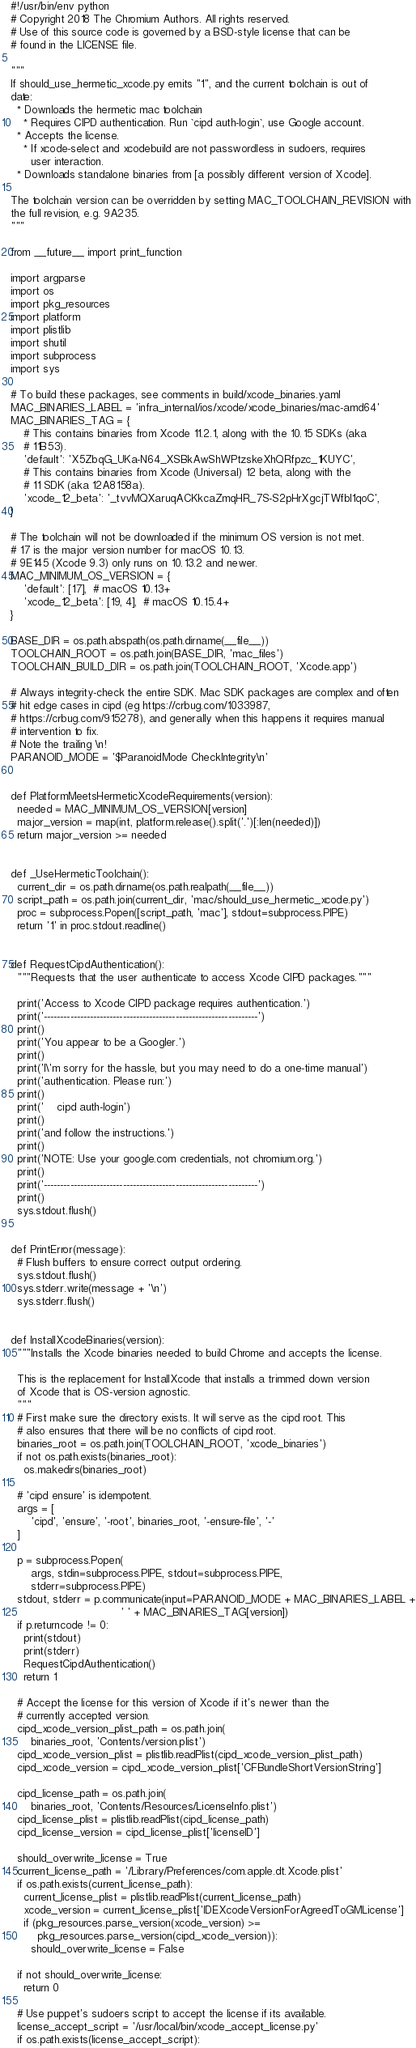<code> <loc_0><loc_0><loc_500><loc_500><_Python_>#!/usr/bin/env python
# Copyright 2018 The Chromium Authors. All rights reserved.
# Use of this source code is governed by a BSD-style license that can be
# found in the LICENSE file.

"""
If should_use_hermetic_xcode.py emits "1", and the current toolchain is out of
date:
  * Downloads the hermetic mac toolchain
    * Requires CIPD authentication. Run `cipd auth-login`, use Google account.
  * Accepts the license.
    * If xcode-select and xcodebuild are not passwordless in sudoers, requires
      user interaction.
  * Downloads standalone binaries from [a possibly different version of Xcode].

The toolchain version can be overridden by setting MAC_TOOLCHAIN_REVISION with
the full revision, e.g. 9A235.
"""

from __future__ import print_function

import argparse
import os
import pkg_resources
import platform
import plistlib
import shutil
import subprocess
import sys

# To build these packages, see comments in build/xcode_binaries.yaml
MAC_BINARIES_LABEL = 'infra_internal/ios/xcode/xcode_binaries/mac-amd64'
MAC_BINARIES_TAG = {
    # This contains binaries from Xcode 11.2.1, along with the 10.15 SDKs (aka
    # 11B53).
    'default': 'X5ZbqG_UKa-N64_XSBkAwShWPtzskeXhQRfpzc_1KUYC',
    # This contains binaries from Xcode (Universal) 12 beta, along with the
    # 11 SDK (aka 12A8158a).
    'xcode_12_beta': '_tvvMQXaruqACKkcaZmqHR_7S-S2pHrXgcjTWfbI1qoC',
}

# The toolchain will not be downloaded if the minimum OS version is not met.
# 17 is the major version number for macOS 10.13.
# 9E145 (Xcode 9.3) only runs on 10.13.2 and newer.
MAC_MINIMUM_OS_VERSION = {
    'default': [17],  # macOS 10.13+
    'xcode_12_beta': [19, 4],  # macOS 10.15.4+
}

BASE_DIR = os.path.abspath(os.path.dirname(__file__))
TOOLCHAIN_ROOT = os.path.join(BASE_DIR, 'mac_files')
TOOLCHAIN_BUILD_DIR = os.path.join(TOOLCHAIN_ROOT, 'Xcode.app')

# Always integrity-check the entire SDK. Mac SDK packages are complex and often
# hit edge cases in cipd (eg https://crbug.com/1033987,
# https://crbug.com/915278), and generally when this happens it requires manual
# intervention to fix.
# Note the trailing \n!
PARANOID_MODE = '$ParanoidMode CheckIntegrity\n'


def PlatformMeetsHermeticXcodeRequirements(version):
  needed = MAC_MINIMUM_OS_VERSION[version]
  major_version = map(int, platform.release().split('.')[:len(needed)])
  return major_version >= needed


def _UseHermeticToolchain():
  current_dir = os.path.dirname(os.path.realpath(__file__))
  script_path = os.path.join(current_dir, 'mac/should_use_hermetic_xcode.py')
  proc = subprocess.Popen([script_path, 'mac'], stdout=subprocess.PIPE)
  return '1' in proc.stdout.readline()


def RequestCipdAuthentication():
  """Requests that the user authenticate to access Xcode CIPD packages."""

  print('Access to Xcode CIPD package requires authentication.')
  print('-----------------------------------------------------------------')
  print()
  print('You appear to be a Googler.')
  print()
  print('I\'m sorry for the hassle, but you may need to do a one-time manual')
  print('authentication. Please run:')
  print()
  print('    cipd auth-login')
  print()
  print('and follow the instructions.')
  print()
  print('NOTE: Use your google.com credentials, not chromium.org.')
  print()
  print('-----------------------------------------------------------------')
  print()
  sys.stdout.flush()


def PrintError(message):
  # Flush buffers to ensure correct output ordering.
  sys.stdout.flush()
  sys.stderr.write(message + '\n')
  sys.stderr.flush()


def InstallXcodeBinaries(version):
  """Installs the Xcode binaries needed to build Chrome and accepts the license.

  This is the replacement for InstallXcode that installs a trimmed down version
  of Xcode that is OS-version agnostic.
  """
  # First make sure the directory exists. It will serve as the cipd root. This
  # also ensures that there will be no conflicts of cipd root.
  binaries_root = os.path.join(TOOLCHAIN_ROOT, 'xcode_binaries')
  if not os.path.exists(binaries_root):
    os.makedirs(binaries_root)

  # 'cipd ensure' is idempotent.
  args = [
      'cipd', 'ensure', '-root', binaries_root, '-ensure-file', '-'
  ]

  p = subprocess.Popen(
      args, stdin=subprocess.PIPE, stdout=subprocess.PIPE,
      stderr=subprocess.PIPE)
  stdout, stderr = p.communicate(input=PARANOID_MODE + MAC_BINARIES_LABEL +
                                 ' ' + MAC_BINARIES_TAG[version])
  if p.returncode != 0:
    print(stdout)
    print(stderr)
    RequestCipdAuthentication()
    return 1

  # Accept the license for this version of Xcode if it's newer than the
  # currently accepted version.
  cipd_xcode_version_plist_path = os.path.join(
      binaries_root, 'Contents/version.plist')
  cipd_xcode_version_plist = plistlib.readPlist(cipd_xcode_version_plist_path)
  cipd_xcode_version = cipd_xcode_version_plist['CFBundleShortVersionString']

  cipd_license_path = os.path.join(
      binaries_root, 'Contents/Resources/LicenseInfo.plist')
  cipd_license_plist = plistlib.readPlist(cipd_license_path)
  cipd_license_version = cipd_license_plist['licenseID']

  should_overwrite_license = True
  current_license_path = '/Library/Preferences/com.apple.dt.Xcode.plist'
  if os.path.exists(current_license_path):
    current_license_plist = plistlib.readPlist(current_license_path)
    xcode_version = current_license_plist['IDEXcodeVersionForAgreedToGMLicense']
    if (pkg_resources.parse_version(xcode_version) >=
        pkg_resources.parse_version(cipd_xcode_version)):
      should_overwrite_license = False

  if not should_overwrite_license:
    return 0

  # Use puppet's sudoers script to accept the license if its available.
  license_accept_script = '/usr/local/bin/xcode_accept_license.py'
  if os.path.exists(license_accept_script):</code> 